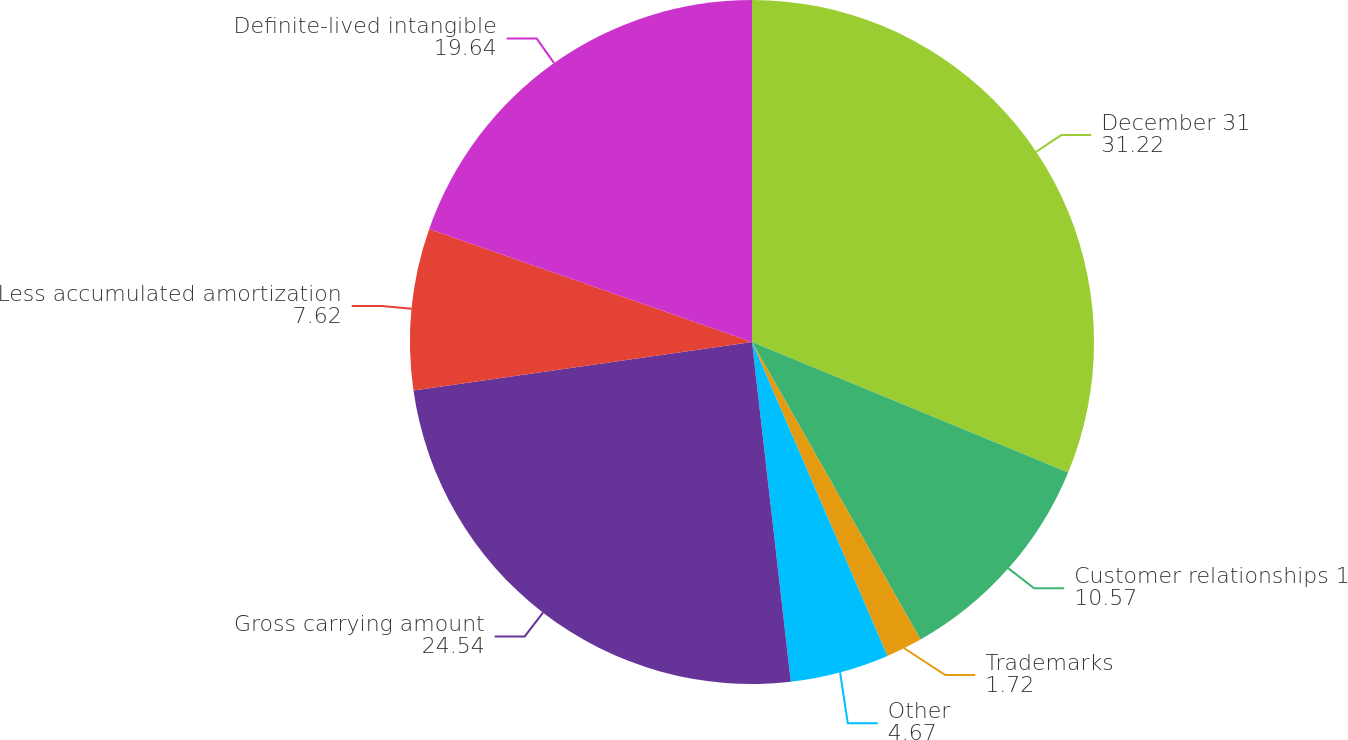Convert chart to OTSL. <chart><loc_0><loc_0><loc_500><loc_500><pie_chart><fcel>December 31<fcel>Customer relationships 1<fcel>Trademarks<fcel>Other<fcel>Gross carrying amount<fcel>Less accumulated amortization<fcel>Definite-lived intangible<nl><fcel>31.22%<fcel>10.57%<fcel>1.72%<fcel>4.67%<fcel>24.54%<fcel>7.62%<fcel>19.64%<nl></chart> 